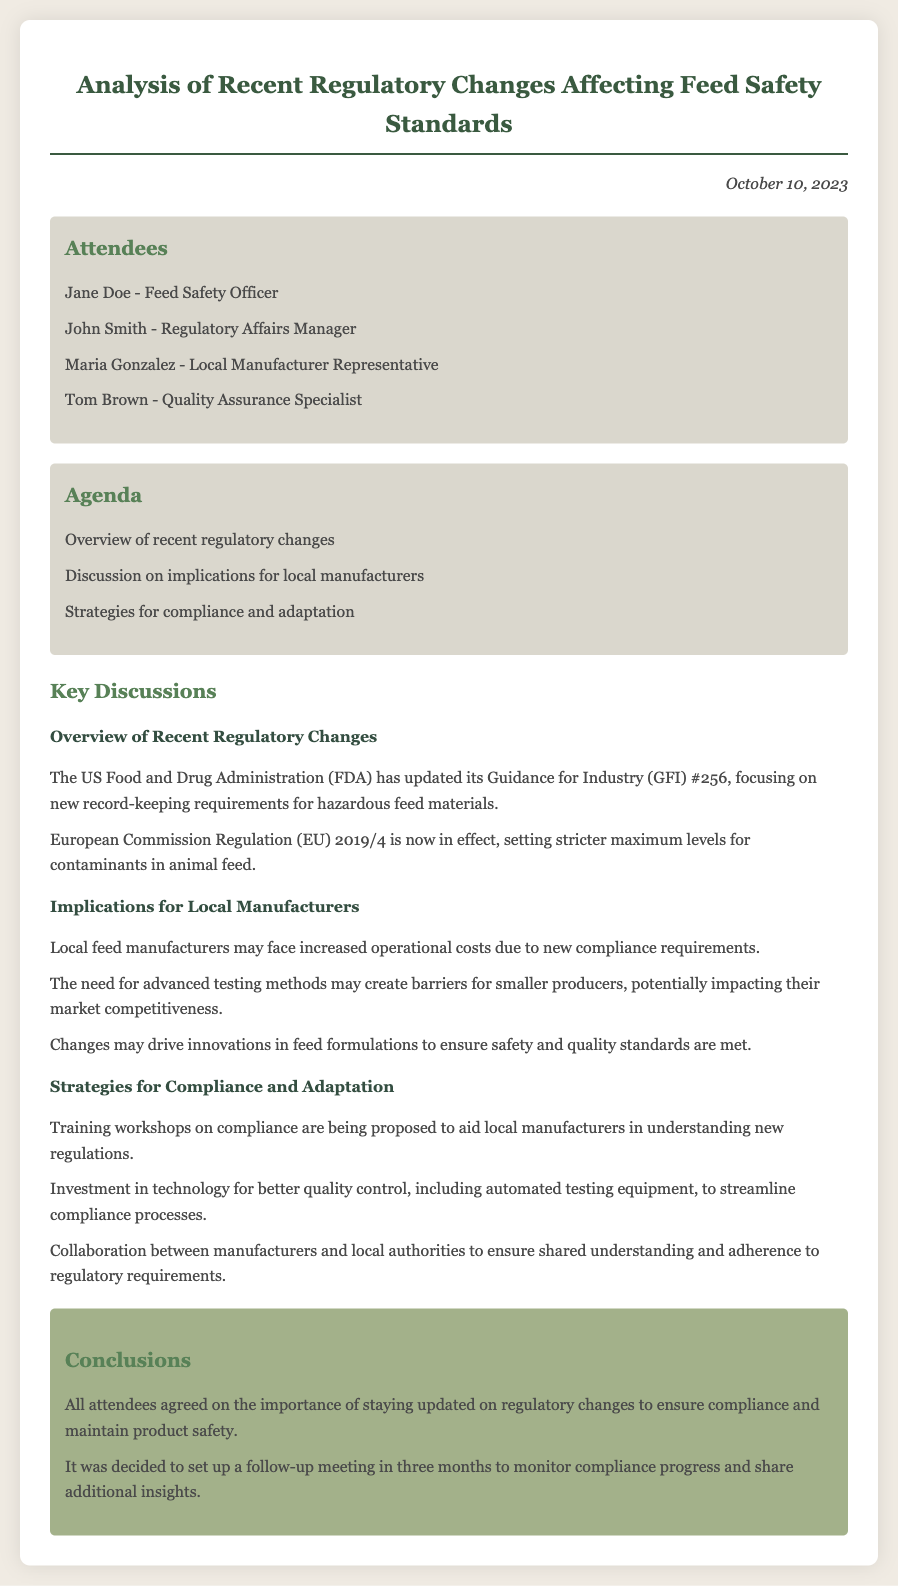What is the date of the meeting? The date of the meeting is mentioned at the top of the document.
Answer: October 10, 2023 Who is the Feed Safety Officer? The document lists attendees, including their roles.
Answer: Jane Doe What is one regulatory change discussed? The key discussions section highlights specific regulatory changes.
Answer: GFI #256 What implication may local manufacturers face? The implications section outlines potential challenges for manufacturers.
Answer: Increased operational costs What is a proposed strategy for compliance? The strategies section lists methods to assist manufacturers.
Answer: Training workshops Who represented local manufacturers? The list of attendees indicates who participated from the manufacturing sector.
Answer: Maria Gonzalez How frequently will follow-up meetings occur? The conclusions section states plans for future meetings.
Answer: In three months What regulation affects maximum contaminant levels? The overview section specifies a regulation related to contaminants.
Answer: EU 2019/4 What is a benefit of collaboration mentioned? The key discussions section addresses collaboration's role in compliance.
Answer: Shared understanding 